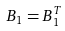<formula> <loc_0><loc_0><loc_500><loc_500>B _ { 1 } = B _ { 1 } ^ { T }</formula> 